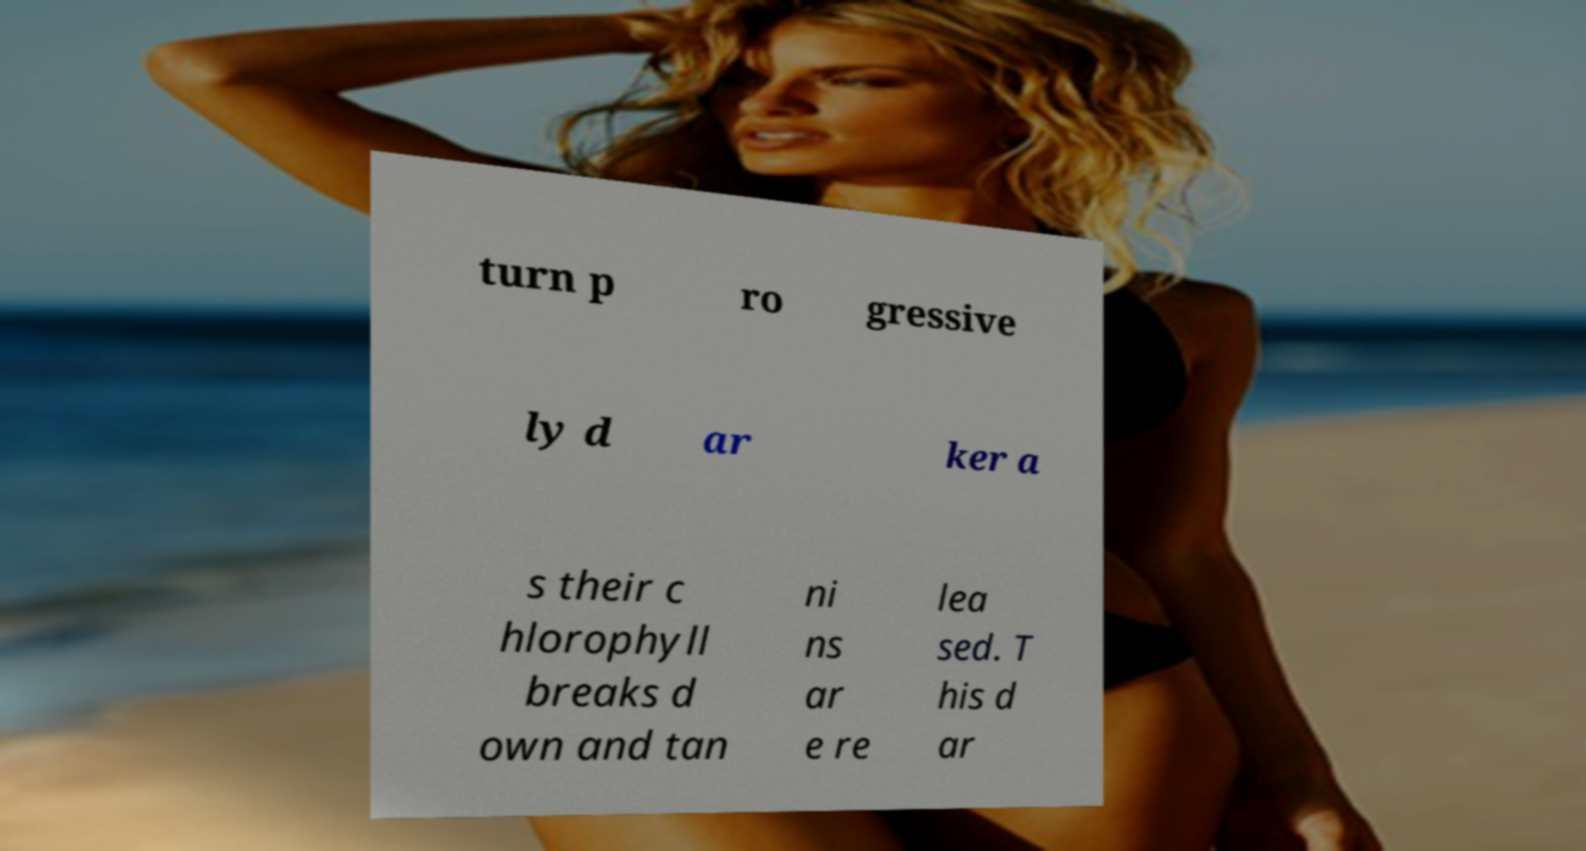There's text embedded in this image that I need extracted. Can you transcribe it verbatim? turn p ro gressive ly d ar ker a s their c hlorophyll breaks d own and tan ni ns ar e re lea sed. T his d ar 